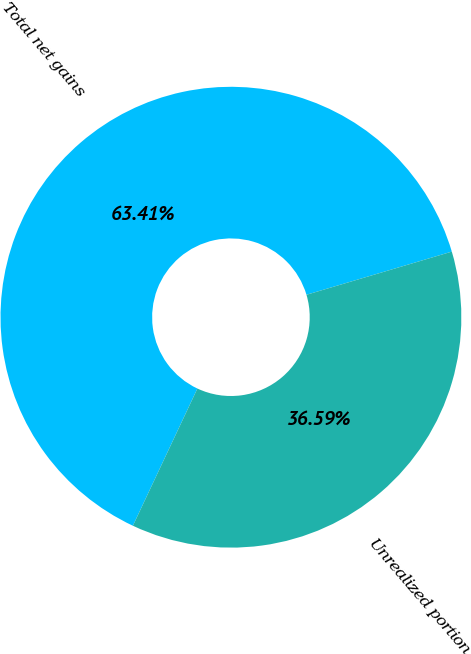<chart> <loc_0><loc_0><loc_500><loc_500><pie_chart><fcel>Total net gains<fcel>Unrealized portion<nl><fcel>63.41%<fcel>36.59%<nl></chart> 